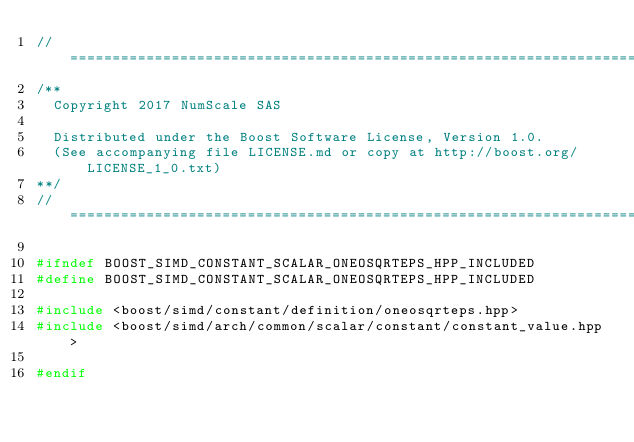Convert code to text. <code><loc_0><loc_0><loc_500><loc_500><_C++_>//==================================================================================================
/**
  Copyright 2017 NumScale SAS

  Distributed under the Boost Software License, Version 1.0.
  (See accompanying file LICENSE.md or copy at http://boost.org/LICENSE_1_0.txt)
**/
//==================================================================================================

#ifndef BOOST_SIMD_CONSTANT_SCALAR_ONEOSQRTEPS_HPP_INCLUDED
#define BOOST_SIMD_CONSTANT_SCALAR_ONEOSQRTEPS_HPP_INCLUDED

#include <boost/simd/constant/definition/oneosqrteps.hpp>
#include <boost/simd/arch/common/scalar/constant/constant_value.hpp>

#endif
</code> 